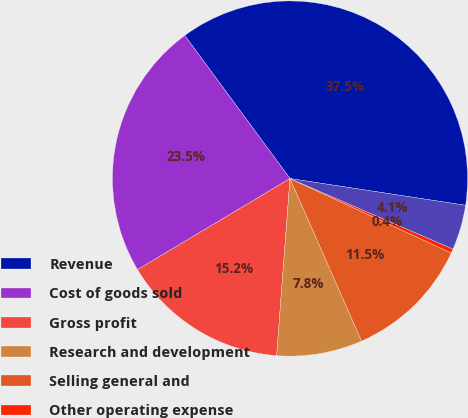Convert chart. <chart><loc_0><loc_0><loc_500><loc_500><pie_chart><fcel>Revenue<fcel>Cost of goods sold<fcel>Gross profit<fcel>Research and development<fcel>Selling general and<fcel>Other operating expense<fcel>Operating income<nl><fcel>37.51%<fcel>23.48%<fcel>15.23%<fcel>7.8%<fcel>11.52%<fcel>0.38%<fcel>4.09%<nl></chart> 